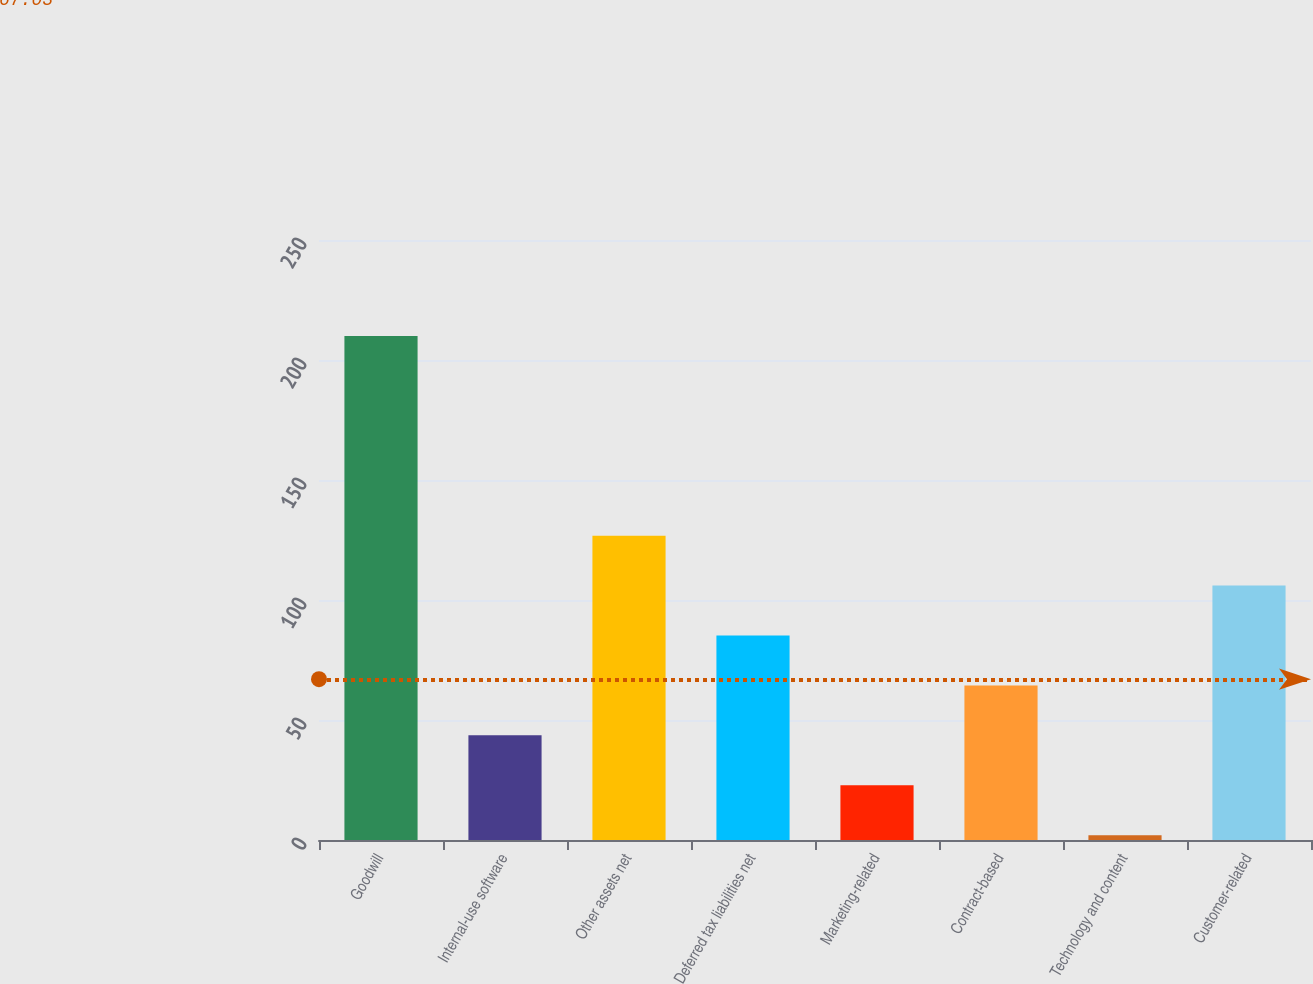Convert chart. <chart><loc_0><loc_0><loc_500><loc_500><bar_chart><fcel>Goodwill<fcel>Internal-use software<fcel>Other assets net<fcel>Deferred tax liabilities net<fcel>Marketing-related<fcel>Contract-based<fcel>Technology and content<fcel>Customer-related<nl><fcel>210<fcel>43.6<fcel>126.8<fcel>85.2<fcel>22.8<fcel>64.4<fcel>2<fcel>106<nl></chart> 